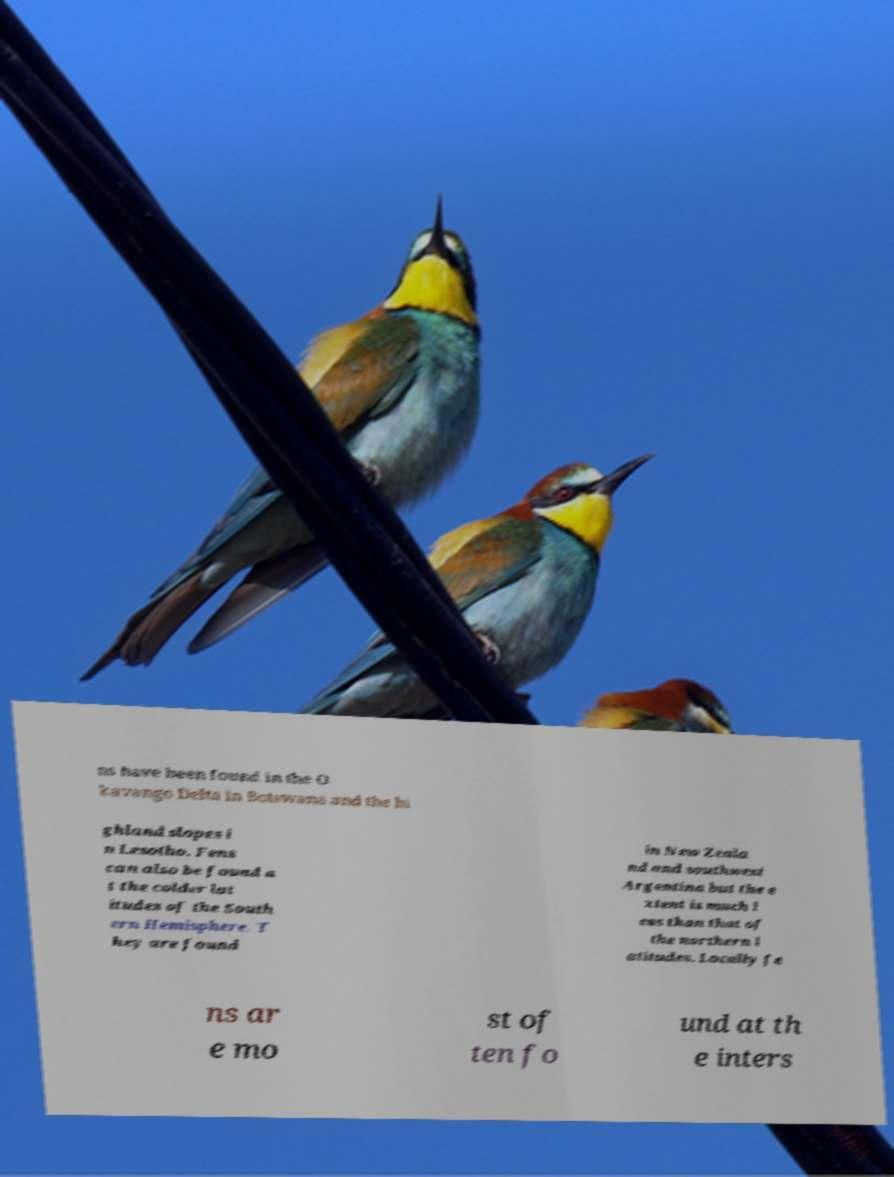There's text embedded in this image that I need extracted. Can you transcribe it verbatim? ns have been found in the O kavango Delta in Botswana and the hi ghland slopes i n Lesotho. Fens can also be found a t the colder lat itudes of the South ern Hemisphere. T hey are found in New Zeala nd and southwest Argentina but the e xtent is much l ess than that of the northern l atitudes. Locally fe ns ar e mo st of ten fo und at th e inters 